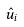Convert formula to latex. <formula><loc_0><loc_0><loc_500><loc_500>\hat { u _ { i } }</formula> 